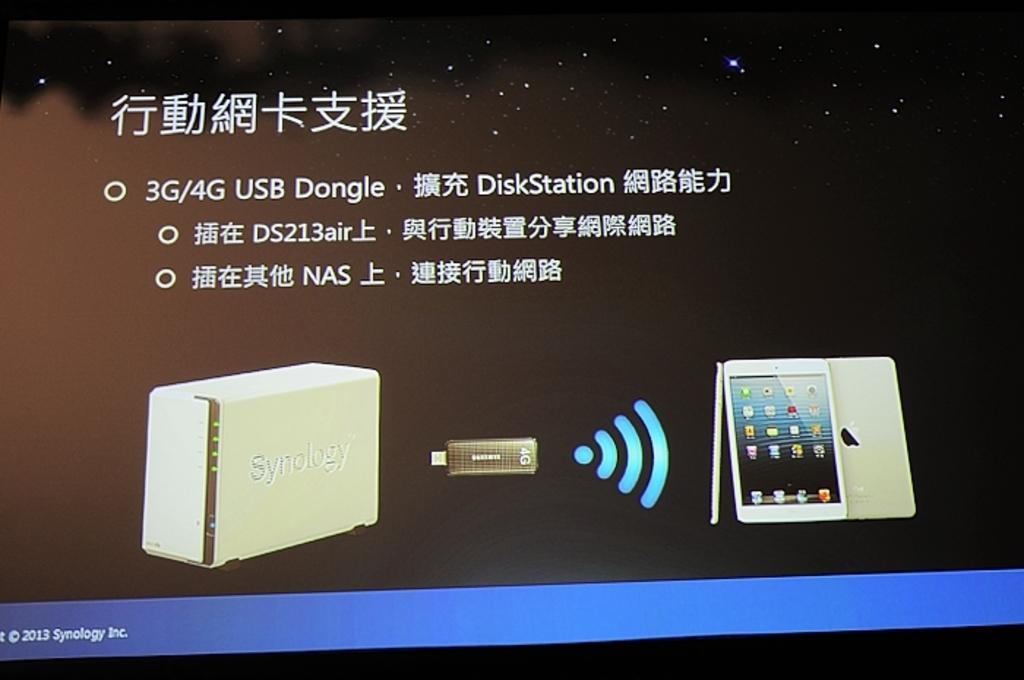What is the main object in the image? There is a screen in the image. What is displayed on the screen? The screen displays a device. Can you describe the device on the screen? A pen drive and a tab are visible on the screen. How does the toad on the screen request more information? There is no toad present on the screen; it only displays a device with a pen drive and a tab. 